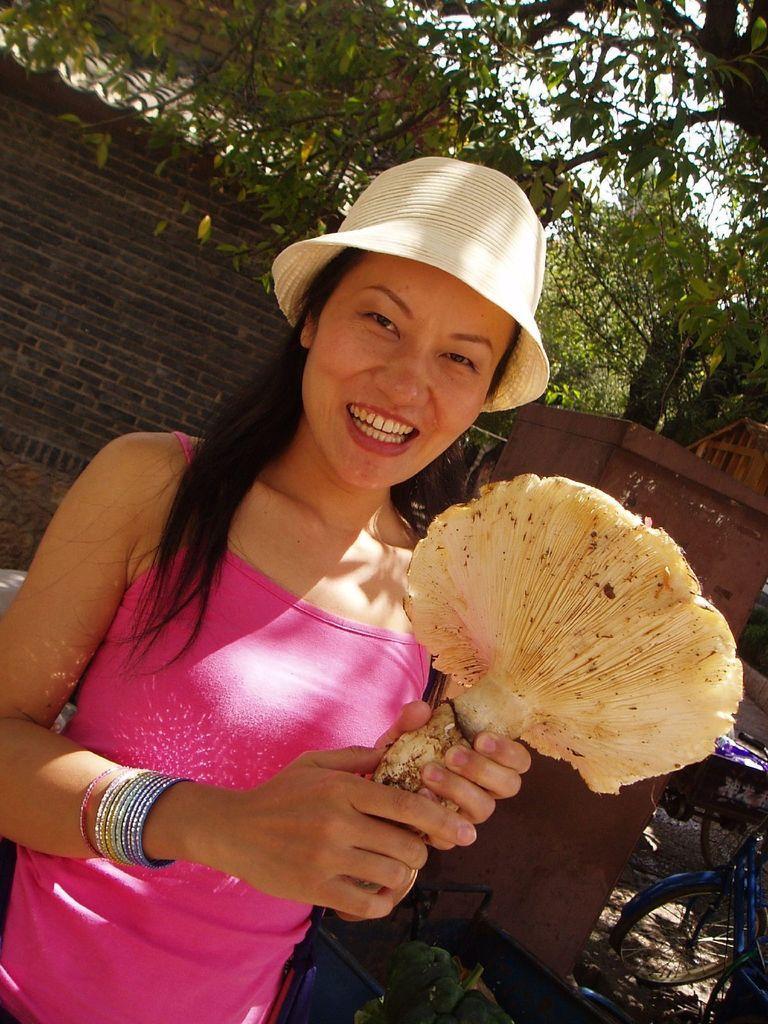Can you describe this image briefly? Here in this picture we can see a woman standing over a place and we can see she is holding something in her hand and smiling and she is also wearing hat and behind her we can see a wall and behind that we can see plants and trees present. 